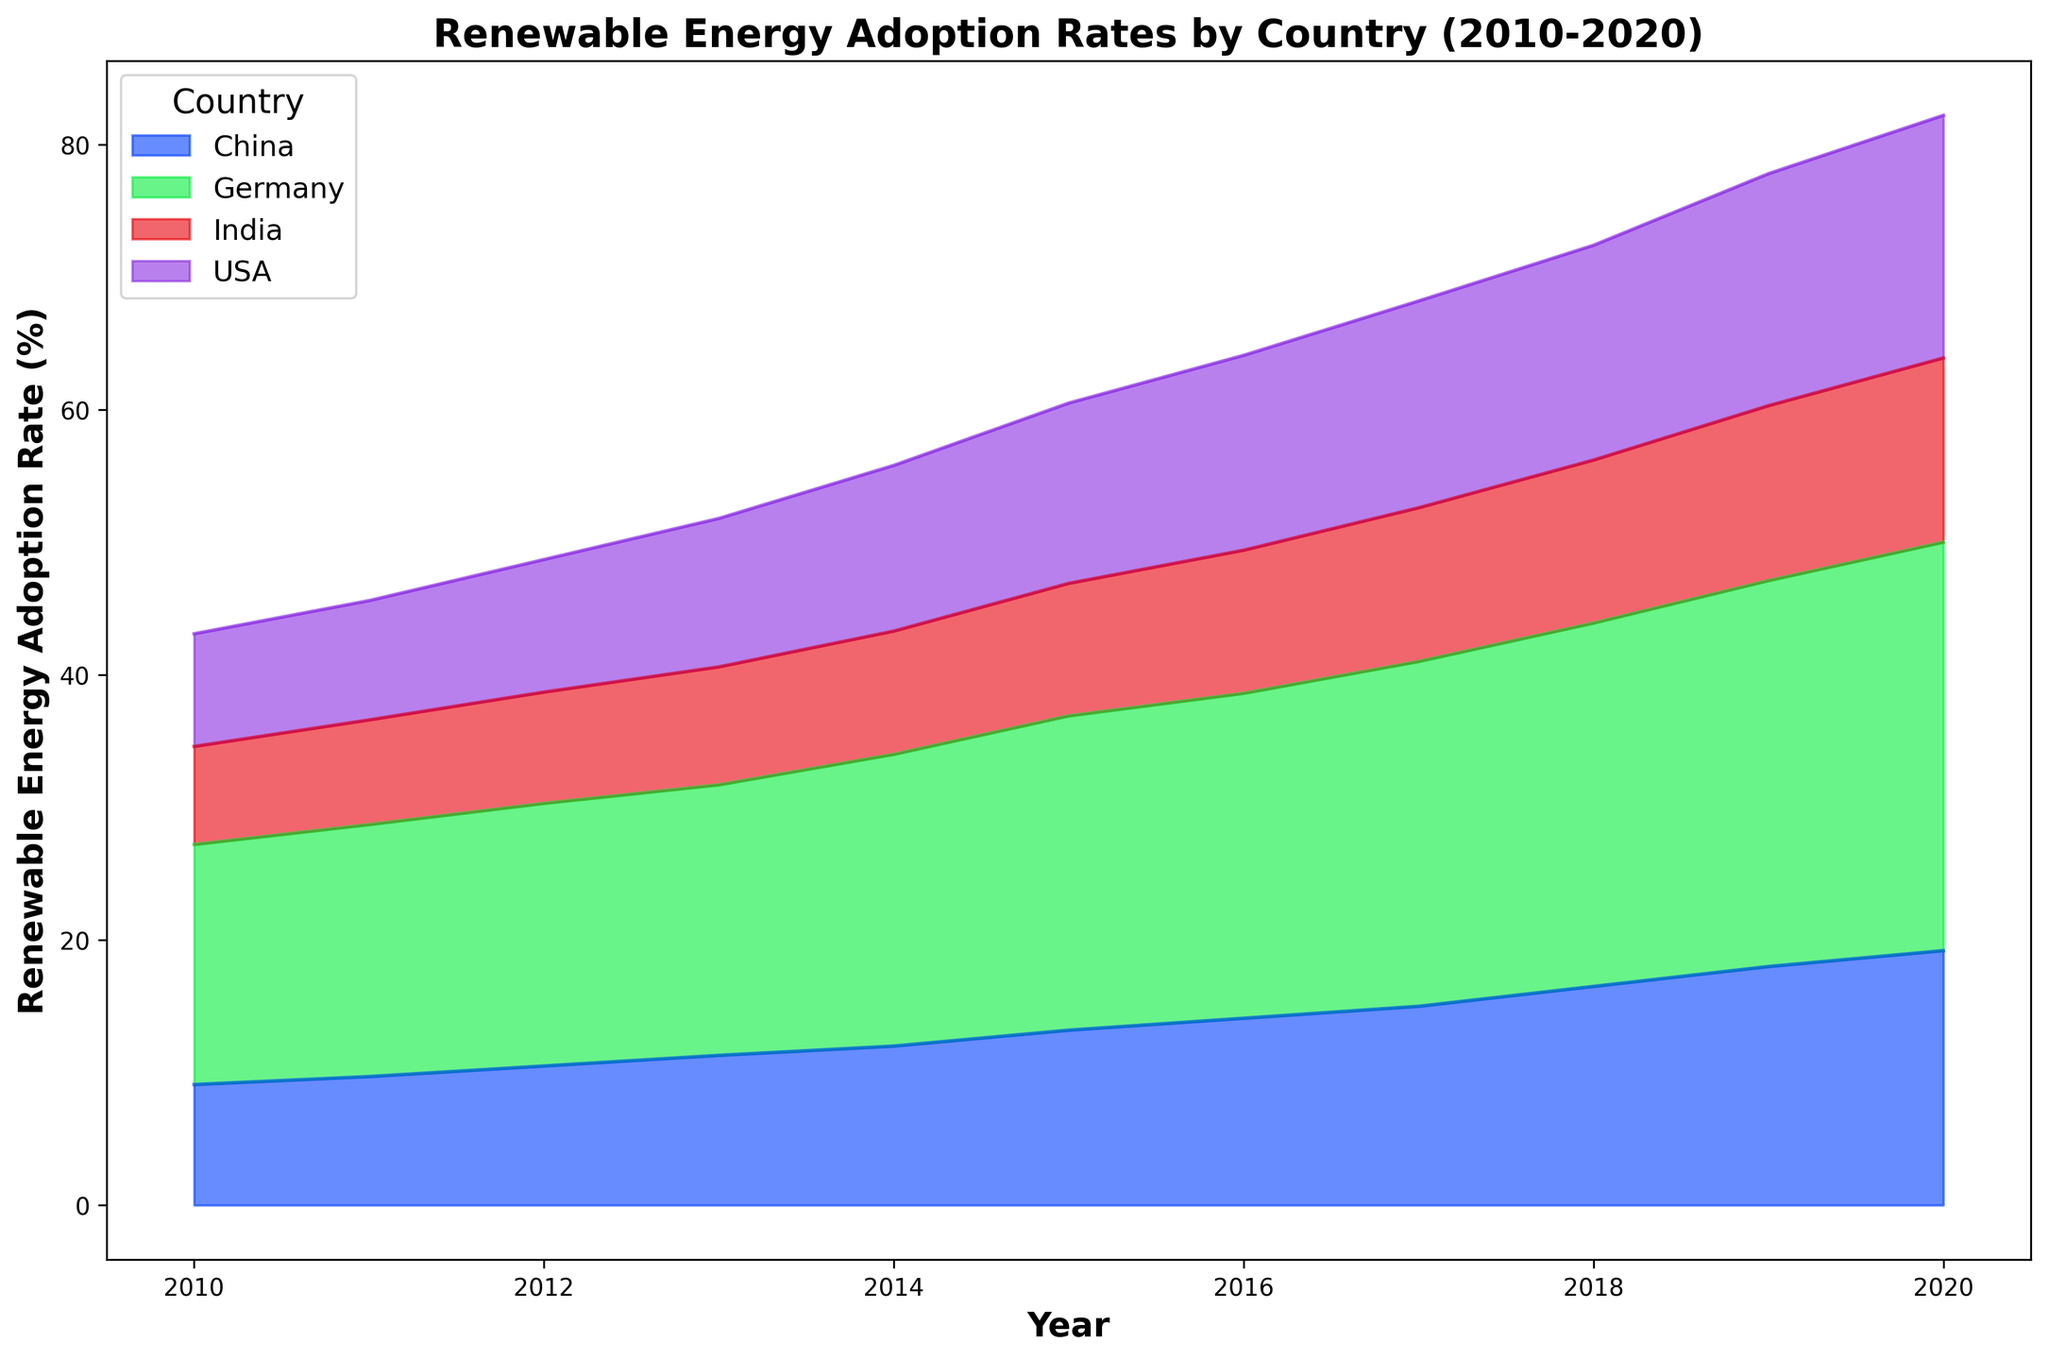Which country had the highest renewable energy adoption rate in 2020? Look at the heights of the areas at the year 2020. The highest category belongs to Germany with 30.8%.
Answer: Germany Between 2010 and 2020, which country showed the most consistent annual increase in renewable energy adoption rates? Compare the slopes of the lines for each country. The slope for Germany shows the most consistent increase.
Answer: Germany What is the difference in renewable energy adoption rates between USA and China in 2020? Look at the heights of the areas for USA and China in 2020. USA is at 18.3% and China is at 19.2%, so the difference is 19.2% - 18.3% = 0.9%.
Answer: 0.9% Which country had the least renewable energy adoption rate in 2018, and what was the rate? Compare the height of the areas for all countries in 2018. India had the least rate at 12.3%.
Answer: India, 12.3% In which year did Germany surpass a 25% adoption rate? Observe Germany’s area representation over the years. The area passes the 25% mark in 2017.
Answer: 2017 By how much did India's renewable energy adoption rate increase from 2010 to 2020? Check the start and end heights for India from 2010 to 2020. India’s rates were 7.4% in 2010 and 13.9% in 2020, so the increase is 13.9% - 7.4% = 6.5%.
Answer: 6.5% Which country had the largest increase in renewable energy adoption rate between 2010 and 2020? Calculate the difference for each country’s start and end points. Germany had the largest increase from 18.1% in 2010 to 30.8% in 2020, which is a 12.7% increase.
Answer: Germany Compare the renewable energy adoption rate of China in 2015 to that of the USA in the same year. Check the heights of the areas for China and USA in 2015. China is at 13.2% and USA is at 13.6%. The USA has a slightly greater rate.
Answer: USA What is the average renewable energy adoption rate for Germany over the period from 2010 to 2020? Sum the adoption rates for Germany from 2010 to 2020 and divide by 11. The total is 221.8%, so the average is 221.8% / 11 = 20.165%.
Answer: 20.2% (rounded to one decimal place) 